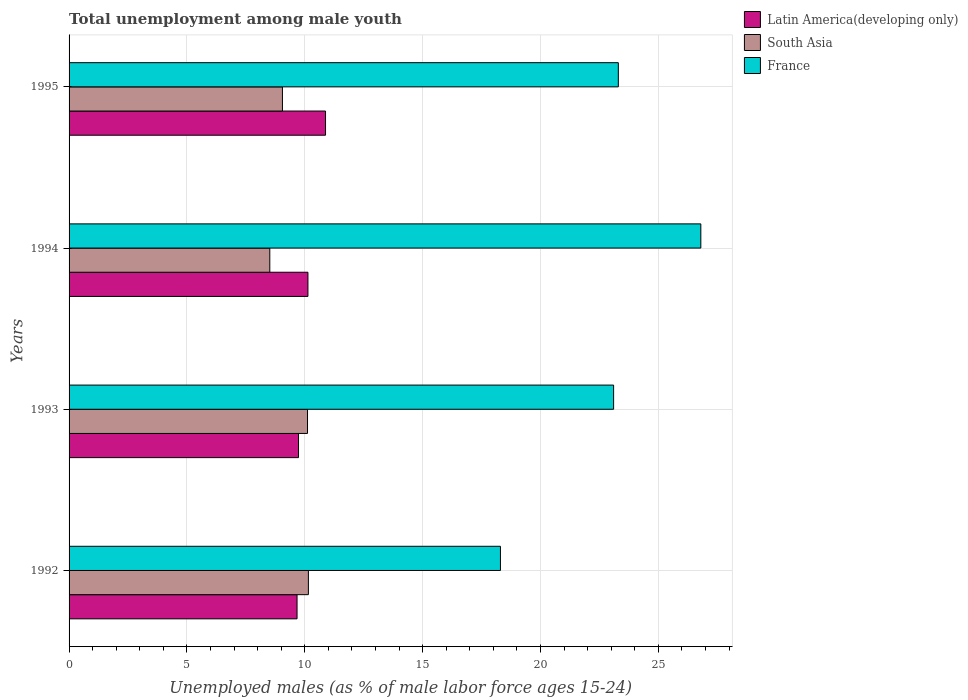Are the number of bars on each tick of the Y-axis equal?
Your answer should be very brief. Yes. What is the label of the 1st group of bars from the top?
Your answer should be compact. 1995. What is the percentage of unemployed males in in Latin America(developing only) in 1993?
Your answer should be very brief. 9.73. Across all years, what is the maximum percentage of unemployed males in in South Asia?
Make the answer very short. 10.15. Across all years, what is the minimum percentage of unemployed males in in Latin America(developing only)?
Ensure brevity in your answer.  9.67. In which year was the percentage of unemployed males in in South Asia maximum?
Provide a short and direct response. 1992. In which year was the percentage of unemployed males in in France minimum?
Give a very brief answer. 1992. What is the total percentage of unemployed males in in France in the graph?
Your answer should be very brief. 91.5. What is the difference between the percentage of unemployed males in in Latin America(developing only) in 1993 and that in 1994?
Provide a short and direct response. -0.4. What is the difference between the percentage of unemployed males in in Latin America(developing only) in 1994 and the percentage of unemployed males in in South Asia in 1992?
Your answer should be compact. -0.02. What is the average percentage of unemployed males in in South Asia per year?
Ensure brevity in your answer.  9.46. In the year 1995, what is the difference between the percentage of unemployed males in in South Asia and percentage of unemployed males in in France?
Give a very brief answer. -14.25. What is the ratio of the percentage of unemployed males in in Latin America(developing only) in 1992 to that in 1994?
Make the answer very short. 0.95. What is the difference between the highest and the second highest percentage of unemployed males in in France?
Provide a succinct answer. 3.5. What is the difference between the highest and the lowest percentage of unemployed males in in Latin America(developing only)?
Provide a short and direct response. 1.21. In how many years, is the percentage of unemployed males in in France greater than the average percentage of unemployed males in in France taken over all years?
Give a very brief answer. 3. Is the sum of the percentage of unemployed males in in France in 1992 and 1995 greater than the maximum percentage of unemployed males in in Latin America(developing only) across all years?
Your answer should be compact. Yes. What does the 1st bar from the bottom in 1993 represents?
Provide a short and direct response. Latin America(developing only). Is it the case that in every year, the sum of the percentage of unemployed males in in France and percentage of unemployed males in in Latin America(developing only) is greater than the percentage of unemployed males in in South Asia?
Provide a short and direct response. Yes. What is the difference between two consecutive major ticks on the X-axis?
Provide a succinct answer. 5. Does the graph contain any zero values?
Provide a succinct answer. No. Where does the legend appear in the graph?
Give a very brief answer. Top right. How many legend labels are there?
Give a very brief answer. 3. How are the legend labels stacked?
Ensure brevity in your answer.  Vertical. What is the title of the graph?
Offer a terse response. Total unemployment among male youth. What is the label or title of the X-axis?
Provide a short and direct response. Unemployed males (as % of male labor force ages 15-24). What is the label or title of the Y-axis?
Provide a succinct answer. Years. What is the Unemployed males (as % of male labor force ages 15-24) in Latin America(developing only) in 1992?
Your answer should be very brief. 9.67. What is the Unemployed males (as % of male labor force ages 15-24) in South Asia in 1992?
Provide a short and direct response. 10.15. What is the Unemployed males (as % of male labor force ages 15-24) in France in 1992?
Keep it short and to the point. 18.3. What is the Unemployed males (as % of male labor force ages 15-24) in Latin America(developing only) in 1993?
Your response must be concise. 9.73. What is the Unemployed males (as % of male labor force ages 15-24) of South Asia in 1993?
Make the answer very short. 10.12. What is the Unemployed males (as % of male labor force ages 15-24) in France in 1993?
Your response must be concise. 23.1. What is the Unemployed males (as % of male labor force ages 15-24) of Latin America(developing only) in 1994?
Offer a very short reply. 10.13. What is the Unemployed males (as % of male labor force ages 15-24) of South Asia in 1994?
Provide a succinct answer. 8.52. What is the Unemployed males (as % of male labor force ages 15-24) in France in 1994?
Offer a terse response. 26.8. What is the Unemployed males (as % of male labor force ages 15-24) of Latin America(developing only) in 1995?
Provide a short and direct response. 10.88. What is the Unemployed males (as % of male labor force ages 15-24) in South Asia in 1995?
Provide a short and direct response. 9.05. What is the Unemployed males (as % of male labor force ages 15-24) of France in 1995?
Your answer should be compact. 23.3. Across all years, what is the maximum Unemployed males (as % of male labor force ages 15-24) of Latin America(developing only)?
Offer a terse response. 10.88. Across all years, what is the maximum Unemployed males (as % of male labor force ages 15-24) of South Asia?
Make the answer very short. 10.15. Across all years, what is the maximum Unemployed males (as % of male labor force ages 15-24) in France?
Your answer should be very brief. 26.8. Across all years, what is the minimum Unemployed males (as % of male labor force ages 15-24) in Latin America(developing only)?
Your answer should be compact. 9.67. Across all years, what is the minimum Unemployed males (as % of male labor force ages 15-24) in South Asia?
Your answer should be very brief. 8.52. Across all years, what is the minimum Unemployed males (as % of male labor force ages 15-24) in France?
Give a very brief answer. 18.3. What is the total Unemployed males (as % of male labor force ages 15-24) in Latin America(developing only) in the graph?
Your answer should be compact. 40.42. What is the total Unemployed males (as % of male labor force ages 15-24) of South Asia in the graph?
Ensure brevity in your answer.  37.83. What is the total Unemployed males (as % of male labor force ages 15-24) of France in the graph?
Your answer should be very brief. 91.5. What is the difference between the Unemployed males (as % of male labor force ages 15-24) of Latin America(developing only) in 1992 and that in 1993?
Keep it short and to the point. -0.06. What is the difference between the Unemployed males (as % of male labor force ages 15-24) of South Asia in 1992 and that in 1993?
Ensure brevity in your answer.  0.04. What is the difference between the Unemployed males (as % of male labor force ages 15-24) of France in 1992 and that in 1993?
Your answer should be very brief. -4.8. What is the difference between the Unemployed males (as % of male labor force ages 15-24) in Latin America(developing only) in 1992 and that in 1994?
Keep it short and to the point. -0.46. What is the difference between the Unemployed males (as % of male labor force ages 15-24) of South Asia in 1992 and that in 1994?
Give a very brief answer. 1.64. What is the difference between the Unemployed males (as % of male labor force ages 15-24) in Latin America(developing only) in 1992 and that in 1995?
Ensure brevity in your answer.  -1.21. What is the difference between the Unemployed males (as % of male labor force ages 15-24) in South Asia in 1992 and that in 1995?
Keep it short and to the point. 1.1. What is the difference between the Unemployed males (as % of male labor force ages 15-24) of Latin America(developing only) in 1993 and that in 1994?
Offer a terse response. -0.4. What is the difference between the Unemployed males (as % of male labor force ages 15-24) in South Asia in 1993 and that in 1994?
Provide a succinct answer. 1.6. What is the difference between the Unemployed males (as % of male labor force ages 15-24) in Latin America(developing only) in 1993 and that in 1995?
Your answer should be very brief. -1.15. What is the difference between the Unemployed males (as % of male labor force ages 15-24) of South Asia in 1993 and that in 1995?
Offer a very short reply. 1.06. What is the difference between the Unemployed males (as % of male labor force ages 15-24) in Latin America(developing only) in 1994 and that in 1995?
Your answer should be very brief. -0.75. What is the difference between the Unemployed males (as % of male labor force ages 15-24) of South Asia in 1994 and that in 1995?
Keep it short and to the point. -0.54. What is the difference between the Unemployed males (as % of male labor force ages 15-24) of Latin America(developing only) in 1992 and the Unemployed males (as % of male labor force ages 15-24) of South Asia in 1993?
Offer a very short reply. -0.44. What is the difference between the Unemployed males (as % of male labor force ages 15-24) of Latin America(developing only) in 1992 and the Unemployed males (as % of male labor force ages 15-24) of France in 1993?
Your answer should be compact. -13.43. What is the difference between the Unemployed males (as % of male labor force ages 15-24) in South Asia in 1992 and the Unemployed males (as % of male labor force ages 15-24) in France in 1993?
Your answer should be compact. -12.95. What is the difference between the Unemployed males (as % of male labor force ages 15-24) of Latin America(developing only) in 1992 and the Unemployed males (as % of male labor force ages 15-24) of South Asia in 1994?
Your response must be concise. 1.16. What is the difference between the Unemployed males (as % of male labor force ages 15-24) of Latin America(developing only) in 1992 and the Unemployed males (as % of male labor force ages 15-24) of France in 1994?
Provide a succinct answer. -17.13. What is the difference between the Unemployed males (as % of male labor force ages 15-24) of South Asia in 1992 and the Unemployed males (as % of male labor force ages 15-24) of France in 1994?
Your response must be concise. -16.65. What is the difference between the Unemployed males (as % of male labor force ages 15-24) of Latin America(developing only) in 1992 and the Unemployed males (as % of male labor force ages 15-24) of South Asia in 1995?
Provide a succinct answer. 0.62. What is the difference between the Unemployed males (as % of male labor force ages 15-24) of Latin America(developing only) in 1992 and the Unemployed males (as % of male labor force ages 15-24) of France in 1995?
Keep it short and to the point. -13.63. What is the difference between the Unemployed males (as % of male labor force ages 15-24) in South Asia in 1992 and the Unemployed males (as % of male labor force ages 15-24) in France in 1995?
Provide a short and direct response. -13.15. What is the difference between the Unemployed males (as % of male labor force ages 15-24) of Latin America(developing only) in 1993 and the Unemployed males (as % of male labor force ages 15-24) of South Asia in 1994?
Keep it short and to the point. 1.22. What is the difference between the Unemployed males (as % of male labor force ages 15-24) in Latin America(developing only) in 1993 and the Unemployed males (as % of male labor force ages 15-24) in France in 1994?
Your response must be concise. -17.07. What is the difference between the Unemployed males (as % of male labor force ages 15-24) of South Asia in 1993 and the Unemployed males (as % of male labor force ages 15-24) of France in 1994?
Make the answer very short. -16.68. What is the difference between the Unemployed males (as % of male labor force ages 15-24) of Latin America(developing only) in 1993 and the Unemployed males (as % of male labor force ages 15-24) of South Asia in 1995?
Your response must be concise. 0.68. What is the difference between the Unemployed males (as % of male labor force ages 15-24) of Latin America(developing only) in 1993 and the Unemployed males (as % of male labor force ages 15-24) of France in 1995?
Offer a terse response. -13.57. What is the difference between the Unemployed males (as % of male labor force ages 15-24) in South Asia in 1993 and the Unemployed males (as % of male labor force ages 15-24) in France in 1995?
Your answer should be very brief. -13.18. What is the difference between the Unemployed males (as % of male labor force ages 15-24) in Latin America(developing only) in 1994 and the Unemployed males (as % of male labor force ages 15-24) in South Asia in 1995?
Ensure brevity in your answer.  1.08. What is the difference between the Unemployed males (as % of male labor force ages 15-24) of Latin America(developing only) in 1994 and the Unemployed males (as % of male labor force ages 15-24) of France in 1995?
Offer a very short reply. -13.17. What is the difference between the Unemployed males (as % of male labor force ages 15-24) of South Asia in 1994 and the Unemployed males (as % of male labor force ages 15-24) of France in 1995?
Provide a short and direct response. -14.78. What is the average Unemployed males (as % of male labor force ages 15-24) in Latin America(developing only) per year?
Offer a terse response. 10.1. What is the average Unemployed males (as % of male labor force ages 15-24) of South Asia per year?
Make the answer very short. 9.46. What is the average Unemployed males (as % of male labor force ages 15-24) in France per year?
Offer a terse response. 22.88. In the year 1992, what is the difference between the Unemployed males (as % of male labor force ages 15-24) in Latin America(developing only) and Unemployed males (as % of male labor force ages 15-24) in South Asia?
Make the answer very short. -0.48. In the year 1992, what is the difference between the Unemployed males (as % of male labor force ages 15-24) in Latin America(developing only) and Unemployed males (as % of male labor force ages 15-24) in France?
Offer a very short reply. -8.63. In the year 1992, what is the difference between the Unemployed males (as % of male labor force ages 15-24) of South Asia and Unemployed males (as % of male labor force ages 15-24) of France?
Your response must be concise. -8.15. In the year 1993, what is the difference between the Unemployed males (as % of male labor force ages 15-24) of Latin America(developing only) and Unemployed males (as % of male labor force ages 15-24) of South Asia?
Offer a very short reply. -0.38. In the year 1993, what is the difference between the Unemployed males (as % of male labor force ages 15-24) of Latin America(developing only) and Unemployed males (as % of male labor force ages 15-24) of France?
Provide a short and direct response. -13.37. In the year 1993, what is the difference between the Unemployed males (as % of male labor force ages 15-24) in South Asia and Unemployed males (as % of male labor force ages 15-24) in France?
Give a very brief answer. -12.98. In the year 1994, what is the difference between the Unemployed males (as % of male labor force ages 15-24) of Latin America(developing only) and Unemployed males (as % of male labor force ages 15-24) of South Asia?
Make the answer very short. 1.62. In the year 1994, what is the difference between the Unemployed males (as % of male labor force ages 15-24) of Latin America(developing only) and Unemployed males (as % of male labor force ages 15-24) of France?
Keep it short and to the point. -16.67. In the year 1994, what is the difference between the Unemployed males (as % of male labor force ages 15-24) of South Asia and Unemployed males (as % of male labor force ages 15-24) of France?
Your answer should be very brief. -18.28. In the year 1995, what is the difference between the Unemployed males (as % of male labor force ages 15-24) of Latin America(developing only) and Unemployed males (as % of male labor force ages 15-24) of South Asia?
Provide a short and direct response. 1.83. In the year 1995, what is the difference between the Unemployed males (as % of male labor force ages 15-24) of Latin America(developing only) and Unemployed males (as % of male labor force ages 15-24) of France?
Give a very brief answer. -12.42. In the year 1995, what is the difference between the Unemployed males (as % of male labor force ages 15-24) of South Asia and Unemployed males (as % of male labor force ages 15-24) of France?
Offer a terse response. -14.25. What is the ratio of the Unemployed males (as % of male labor force ages 15-24) in Latin America(developing only) in 1992 to that in 1993?
Your answer should be compact. 0.99. What is the ratio of the Unemployed males (as % of male labor force ages 15-24) in France in 1992 to that in 1993?
Offer a terse response. 0.79. What is the ratio of the Unemployed males (as % of male labor force ages 15-24) in Latin America(developing only) in 1992 to that in 1994?
Offer a terse response. 0.95. What is the ratio of the Unemployed males (as % of male labor force ages 15-24) of South Asia in 1992 to that in 1994?
Your answer should be compact. 1.19. What is the ratio of the Unemployed males (as % of male labor force ages 15-24) in France in 1992 to that in 1994?
Give a very brief answer. 0.68. What is the ratio of the Unemployed males (as % of male labor force ages 15-24) of Latin America(developing only) in 1992 to that in 1995?
Your answer should be very brief. 0.89. What is the ratio of the Unemployed males (as % of male labor force ages 15-24) in South Asia in 1992 to that in 1995?
Offer a terse response. 1.12. What is the ratio of the Unemployed males (as % of male labor force ages 15-24) in France in 1992 to that in 1995?
Offer a terse response. 0.79. What is the ratio of the Unemployed males (as % of male labor force ages 15-24) in Latin America(developing only) in 1993 to that in 1994?
Make the answer very short. 0.96. What is the ratio of the Unemployed males (as % of male labor force ages 15-24) in South Asia in 1993 to that in 1994?
Give a very brief answer. 1.19. What is the ratio of the Unemployed males (as % of male labor force ages 15-24) of France in 1993 to that in 1994?
Provide a short and direct response. 0.86. What is the ratio of the Unemployed males (as % of male labor force ages 15-24) in Latin America(developing only) in 1993 to that in 1995?
Offer a terse response. 0.89. What is the ratio of the Unemployed males (as % of male labor force ages 15-24) in South Asia in 1993 to that in 1995?
Keep it short and to the point. 1.12. What is the ratio of the Unemployed males (as % of male labor force ages 15-24) of France in 1993 to that in 1995?
Make the answer very short. 0.99. What is the ratio of the Unemployed males (as % of male labor force ages 15-24) in Latin America(developing only) in 1994 to that in 1995?
Your response must be concise. 0.93. What is the ratio of the Unemployed males (as % of male labor force ages 15-24) in South Asia in 1994 to that in 1995?
Give a very brief answer. 0.94. What is the ratio of the Unemployed males (as % of male labor force ages 15-24) in France in 1994 to that in 1995?
Your response must be concise. 1.15. What is the difference between the highest and the second highest Unemployed males (as % of male labor force ages 15-24) of Latin America(developing only)?
Provide a succinct answer. 0.75. What is the difference between the highest and the second highest Unemployed males (as % of male labor force ages 15-24) in South Asia?
Your answer should be compact. 0.04. What is the difference between the highest and the lowest Unemployed males (as % of male labor force ages 15-24) of Latin America(developing only)?
Keep it short and to the point. 1.21. What is the difference between the highest and the lowest Unemployed males (as % of male labor force ages 15-24) of South Asia?
Offer a terse response. 1.64. What is the difference between the highest and the lowest Unemployed males (as % of male labor force ages 15-24) in France?
Provide a short and direct response. 8.5. 